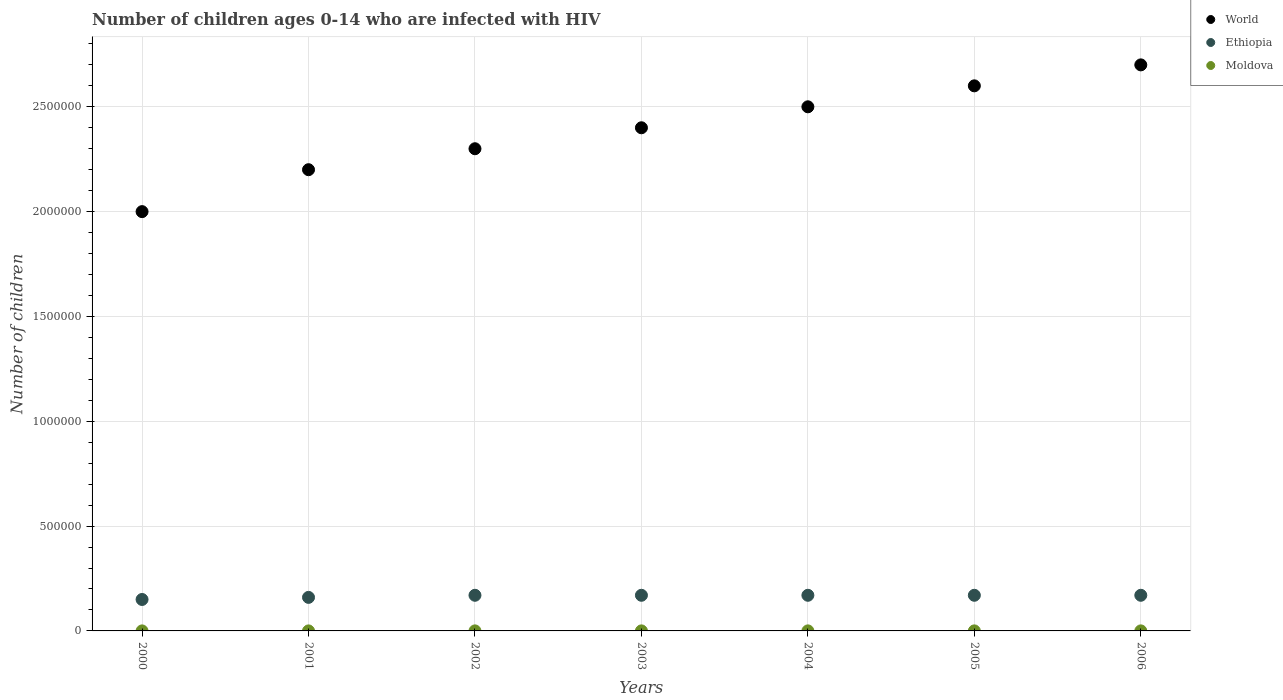Is the number of dotlines equal to the number of legend labels?
Keep it short and to the point. Yes. What is the number of HIV infected children in World in 2001?
Provide a short and direct response. 2.20e+06. Across all years, what is the maximum number of HIV infected children in Moldova?
Provide a short and direct response. 200. Across all years, what is the minimum number of HIV infected children in Ethiopia?
Your answer should be very brief. 1.50e+05. What is the total number of HIV infected children in Moldova in the graph?
Ensure brevity in your answer.  1200. What is the difference between the number of HIV infected children in World in 2003 and that in 2004?
Your response must be concise. -1.00e+05. What is the difference between the number of HIV infected children in Moldova in 2006 and the number of HIV infected children in World in 2002?
Provide a short and direct response. -2.30e+06. What is the average number of HIV infected children in Moldova per year?
Provide a short and direct response. 171.43. In the year 2000, what is the difference between the number of HIV infected children in World and number of HIV infected children in Moldova?
Keep it short and to the point. 2.00e+06. In how many years, is the number of HIV infected children in Ethiopia greater than 600000?
Provide a short and direct response. 0. What is the ratio of the number of HIV infected children in Moldova in 2001 to that in 2006?
Your answer should be very brief. 0.5. What is the difference between the highest and the lowest number of HIV infected children in World?
Give a very brief answer. 7.00e+05. In how many years, is the number of HIV infected children in Moldova greater than the average number of HIV infected children in Moldova taken over all years?
Your response must be concise. 5. Is the sum of the number of HIV infected children in World in 2001 and 2004 greater than the maximum number of HIV infected children in Moldova across all years?
Offer a terse response. Yes. Is it the case that in every year, the sum of the number of HIV infected children in World and number of HIV infected children in Moldova  is greater than the number of HIV infected children in Ethiopia?
Your response must be concise. Yes. Does the number of HIV infected children in Moldova monotonically increase over the years?
Offer a very short reply. No. How many dotlines are there?
Give a very brief answer. 3. How many years are there in the graph?
Your response must be concise. 7. What is the difference between two consecutive major ticks on the Y-axis?
Offer a terse response. 5.00e+05. Are the values on the major ticks of Y-axis written in scientific E-notation?
Ensure brevity in your answer.  No. Does the graph contain any zero values?
Your answer should be very brief. No. How many legend labels are there?
Keep it short and to the point. 3. How are the legend labels stacked?
Your answer should be very brief. Vertical. What is the title of the graph?
Keep it short and to the point. Number of children ages 0-14 who are infected with HIV. Does "Peru" appear as one of the legend labels in the graph?
Offer a terse response. No. What is the label or title of the Y-axis?
Your answer should be compact. Number of children. What is the Number of children in Ethiopia in 2000?
Make the answer very short. 1.50e+05. What is the Number of children in Moldova in 2000?
Provide a succinct answer. 100. What is the Number of children in World in 2001?
Ensure brevity in your answer.  2.20e+06. What is the Number of children of Moldova in 2001?
Ensure brevity in your answer.  100. What is the Number of children in World in 2002?
Offer a very short reply. 2.30e+06. What is the Number of children of World in 2003?
Make the answer very short. 2.40e+06. What is the Number of children of World in 2004?
Give a very brief answer. 2.50e+06. What is the Number of children in Ethiopia in 2004?
Offer a terse response. 1.70e+05. What is the Number of children in Moldova in 2004?
Offer a very short reply. 200. What is the Number of children of World in 2005?
Your answer should be compact. 2.60e+06. What is the Number of children of Ethiopia in 2005?
Your response must be concise. 1.70e+05. What is the Number of children in World in 2006?
Your answer should be compact. 2.70e+06. What is the Number of children of Ethiopia in 2006?
Give a very brief answer. 1.70e+05. What is the Number of children of Moldova in 2006?
Your response must be concise. 200. Across all years, what is the maximum Number of children in World?
Your response must be concise. 2.70e+06. Across all years, what is the maximum Number of children of Ethiopia?
Your answer should be compact. 1.70e+05. Across all years, what is the maximum Number of children in Moldova?
Make the answer very short. 200. Across all years, what is the minimum Number of children in Ethiopia?
Ensure brevity in your answer.  1.50e+05. Across all years, what is the minimum Number of children of Moldova?
Give a very brief answer. 100. What is the total Number of children of World in the graph?
Your response must be concise. 1.67e+07. What is the total Number of children of Ethiopia in the graph?
Offer a terse response. 1.16e+06. What is the total Number of children of Moldova in the graph?
Your answer should be very brief. 1200. What is the difference between the Number of children in World in 2000 and that in 2001?
Offer a very short reply. -2.00e+05. What is the difference between the Number of children of Ethiopia in 2000 and that in 2001?
Provide a short and direct response. -10000. What is the difference between the Number of children in Moldova in 2000 and that in 2001?
Provide a short and direct response. 0. What is the difference between the Number of children of World in 2000 and that in 2002?
Your answer should be very brief. -3.00e+05. What is the difference between the Number of children of Moldova in 2000 and that in 2002?
Offer a very short reply. -100. What is the difference between the Number of children in World in 2000 and that in 2003?
Offer a very short reply. -4.00e+05. What is the difference between the Number of children of Moldova in 2000 and that in 2003?
Give a very brief answer. -100. What is the difference between the Number of children of World in 2000 and that in 2004?
Make the answer very short. -5.00e+05. What is the difference between the Number of children in Moldova in 2000 and that in 2004?
Provide a succinct answer. -100. What is the difference between the Number of children of World in 2000 and that in 2005?
Provide a succinct answer. -6.00e+05. What is the difference between the Number of children in Moldova in 2000 and that in 2005?
Your answer should be compact. -100. What is the difference between the Number of children in World in 2000 and that in 2006?
Keep it short and to the point. -7.00e+05. What is the difference between the Number of children of Moldova in 2000 and that in 2006?
Give a very brief answer. -100. What is the difference between the Number of children in Ethiopia in 2001 and that in 2002?
Provide a short and direct response. -10000. What is the difference between the Number of children of Moldova in 2001 and that in 2002?
Offer a very short reply. -100. What is the difference between the Number of children of World in 2001 and that in 2003?
Your response must be concise. -2.00e+05. What is the difference between the Number of children of Moldova in 2001 and that in 2003?
Make the answer very short. -100. What is the difference between the Number of children of World in 2001 and that in 2004?
Make the answer very short. -3.00e+05. What is the difference between the Number of children in Moldova in 2001 and that in 2004?
Give a very brief answer. -100. What is the difference between the Number of children in World in 2001 and that in 2005?
Give a very brief answer. -4.00e+05. What is the difference between the Number of children in Moldova in 2001 and that in 2005?
Keep it short and to the point. -100. What is the difference between the Number of children of World in 2001 and that in 2006?
Your response must be concise. -5.00e+05. What is the difference between the Number of children of Ethiopia in 2001 and that in 2006?
Provide a succinct answer. -10000. What is the difference between the Number of children of Moldova in 2001 and that in 2006?
Make the answer very short. -100. What is the difference between the Number of children of World in 2002 and that in 2003?
Ensure brevity in your answer.  -1.00e+05. What is the difference between the Number of children in Ethiopia in 2002 and that in 2003?
Give a very brief answer. 0. What is the difference between the Number of children in Moldova in 2002 and that in 2003?
Offer a very short reply. 0. What is the difference between the Number of children in World in 2002 and that in 2004?
Offer a very short reply. -2.00e+05. What is the difference between the Number of children in Ethiopia in 2002 and that in 2005?
Your response must be concise. 0. What is the difference between the Number of children of World in 2002 and that in 2006?
Give a very brief answer. -4.00e+05. What is the difference between the Number of children in Moldova in 2002 and that in 2006?
Keep it short and to the point. 0. What is the difference between the Number of children in Ethiopia in 2003 and that in 2004?
Offer a terse response. 0. What is the difference between the Number of children in Moldova in 2003 and that in 2004?
Ensure brevity in your answer.  0. What is the difference between the Number of children in Moldova in 2003 and that in 2005?
Your response must be concise. 0. What is the difference between the Number of children of World in 2004 and that in 2006?
Provide a short and direct response. -2.00e+05. What is the difference between the Number of children in Ethiopia in 2004 and that in 2006?
Provide a short and direct response. 0. What is the difference between the Number of children of Moldova in 2004 and that in 2006?
Your response must be concise. 0. What is the difference between the Number of children of World in 2005 and that in 2006?
Offer a terse response. -1.00e+05. What is the difference between the Number of children in World in 2000 and the Number of children in Ethiopia in 2001?
Offer a terse response. 1.84e+06. What is the difference between the Number of children of World in 2000 and the Number of children of Moldova in 2001?
Your answer should be compact. 2.00e+06. What is the difference between the Number of children in Ethiopia in 2000 and the Number of children in Moldova in 2001?
Give a very brief answer. 1.50e+05. What is the difference between the Number of children in World in 2000 and the Number of children in Ethiopia in 2002?
Keep it short and to the point. 1.83e+06. What is the difference between the Number of children of World in 2000 and the Number of children of Moldova in 2002?
Make the answer very short. 2.00e+06. What is the difference between the Number of children of Ethiopia in 2000 and the Number of children of Moldova in 2002?
Your answer should be very brief. 1.50e+05. What is the difference between the Number of children of World in 2000 and the Number of children of Ethiopia in 2003?
Provide a short and direct response. 1.83e+06. What is the difference between the Number of children in World in 2000 and the Number of children in Moldova in 2003?
Provide a short and direct response. 2.00e+06. What is the difference between the Number of children of Ethiopia in 2000 and the Number of children of Moldova in 2003?
Give a very brief answer. 1.50e+05. What is the difference between the Number of children in World in 2000 and the Number of children in Ethiopia in 2004?
Keep it short and to the point. 1.83e+06. What is the difference between the Number of children of World in 2000 and the Number of children of Moldova in 2004?
Keep it short and to the point. 2.00e+06. What is the difference between the Number of children of Ethiopia in 2000 and the Number of children of Moldova in 2004?
Your answer should be very brief. 1.50e+05. What is the difference between the Number of children of World in 2000 and the Number of children of Ethiopia in 2005?
Offer a very short reply. 1.83e+06. What is the difference between the Number of children in World in 2000 and the Number of children in Moldova in 2005?
Provide a short and direct response. 2.00e+06. What is the difference between the Number of children in Ethiopia in 2000 and the Number of children in Moldova in 2005?
Your answer should be compact. 1.50e+05. What is the difference between the Number of children in World in 2000 and the Number of children in Ethiopia in 2006?
Provide a succinct answer. 1.83e+06. What is the difference between the Number of children of World in 2000 and the Number of children of Moldova in 2006?
Keep it short and to the point. 2.00e+06. What is the difference between the Number of children in Ethiopia in 2000 and the Number of children in Moldova in 2006?
Give a very brief answer. 1.50e+05. What is the difference between the Number of children in World in 2001 and the Number of children in Ethiopia in 2002?
Offer a terse response. 2.03e+06. What is the difference between the Number of children in World in 2001 and the Number of children in Moldova in 2002?
Your answer should be very brief. 2.20e+06. What is the difference between the Number of children in Ethiopia in 2001 and the Number of children in Moldova in 2002?
Provide a succinct answer. 1.60e+05. What is the difference between the Number of children in World in 2001 and the Number of children in Ethiopia in 2003?
Provide a short and direct response. 2.03e+06. What is the difference between the Number of children in World in 2001 and the Number of children in Moldova in 2003?
Offer a very short reply. 2.20e+06. What is the difference between the Number of children in Ethiopia in 2001 and the Number of children in Moldova in 2003?
Provide a short and direct response. 1.60e+05. What is the difference between the Number of children of World in 2001 and the Number of children of Ethiopia in 2004?
Your answer should be compact. 2.03e+06. What is the difference between the Number of children in World in 2001 and the Number of children in Moldova in 2004?
Give a very brief answer. 2.20e+06. What is the difference between the Number of children of Ethiopia in 2001 and the Number of children of Moldova in 2004?
Ensure brevity in your answer.  1.60e+05. What is the difference between the Number of children in World in 2001 and the Number of children in Ethiopia in 2005?
Provide a succinct answer. 2.03e+06. What is the difference between the Number of children of World in 2001 and the Number of children of Moldova in 2005?
Make the answer very short. 2.20e+06. What is the difference between the Number of children of Ethiopia in 2001 and the Number of children of Moldova in 2005?
Your answer should be compact. 1.60e+05. What is the difference between the Number of children of World in 2001 and the Number of children of Ethiopia in 2006?
Provide a short and direct response. 2.03e+06. What is the difference between the Number of children in World in 2001 and the Number of children in Moldova in 2006?
Your answer should be compact. 2.20e+06. What is the difference between the Number of children of Ethiopia in 2001 and the Number of children of Moldova in 2006?
Your answer should be compact. 1.60e+05. What is the difference between the Number of children in World in 2002 and the Number of children in Ethiopia in 2003?
Provide a succinct answer. 2.13e+06. What is the difference between the Number of children of World in 2002 and the Number of children of Moldova in 2003?
Provide a succinct answer. 2.30e+06. What is the difference between the Number of children of Ethiopia in 2002 and the Number of children of Moldova in 2003?
Offer a terse response. 1.70e+05. What is the difference between the Number of children of World in 2002 and the Number of children of Ethiopia in 2004?
Provide a short and direct response. 2.13e+06. What is the difference between the Number of children in World in 2002 and the Number of children in Moldova in 2004?
Your answer should be compact. 2.30e+06. What is the difference between the Number of children of Ethiopia in 2002 and the Number of children of Moldova in 2004?
Give a very brief answer. 1.70e+05. What is the difference between the Number of children of World in 2002 and the Number of children of Ethiopia in 2005?
Offer a terse response. 2.13e+06. What is the difference between the Number of children in World in 2002 and the Number of children in Moldova in 2005?
Give a very brief answer. 2.30e+06. What is the difference between the Number of children of Ethiopia in 2002 and the Number of children of Moldova in 2005?
Give a very brief answer. 1.70e+05. What is the difference between the Number of children of World in 2002 and the Number of children of Ethiopia in 2006?
Offer a very short reply. 2.13e+06. What is the difference between the Number of children of World in 2002 and the Number of children of Moldova in 2006?
Ensure brevity in your answer.  2.30e+06. What is the difference between the Number of children in Ethiopia in 2002 and the Number of children in Moldova in 2006?
Your response must be concise. 1.70e+05. What is the difference between the Number of children in World in 2003 and the Number of children in Ethiopia in 2004?
Ensure brevity in your answer.  2.23e+06. What is the difference between the Number of children in World in 2003 and the Number of children in Moldova in 2004?
Offer a very short reply. 2.40e+06. What is the difference between the Number of children in Ethiopia in 2003 and the Number of children in Moldova in 2004?
Your answer should be very brief. 1.70e+05. What is the difference between the Number of children in World in 2003 and the Number of children in Ethiopia in 2005?
Ensure brevity in your answer.  2.23e+06. What is the difference between the Number of children of World in 2003 and the Number of children of Moldova in 2005?
Give a very brief answer. 2.40e+06. What is the difference between the Number of children of Ethiopia in 2003 and the Number of children of Moldova in 2005?
Your answer should be compact. 1.70e+05. What is the difference between the Number of children in World in 2003 and the Number of children in Ethiopia in 2006?
Ensure brevity in your answer.  2.23e+06. What is the difference between the Number of children of World in 2003 and the Number of children of Moldova in 2006?
Provide a succinct answer. 2.40e+06. What is the difference between the Number of children in Ethiopia in 2003 and the Number of children in Moldova in 2006?
Offer a very short reply. 1.70e+05. What is the difference between the Number of children of World in 2004 and the Number of children of Ethiopia in 2005?
Give a very brief answer. 2.33e+06. What is the difference between the Number of children of World in 2004 and the Number of children of Moldova in 2005?
Offer a terse response. 2.50e+06. What is the difference between the Number of children of Ethiopia in 2004 and the Number of children of Moldova in 2005?
Make the answer very short. 1.70e+05. What is the difference between the Number of children in World in 2004 and the Number of children in Ethiopia in 2006?
Keep it short and to the point. 2.33e+06. What is the difference between the Number of children in World in 2004 and the Number of children in Moldova in 2006?
Your answer should be compact. 2.50e+06. What is the difference between the Number of children of Ethiopia in 2004 and the Number of children of Moldova in 2006?
Give a very brief answer. 1.70e+05. What is the difference between the Number of children of World in 2005 and the Number of children of Ethiopia in 2006?
Ensure brevity in your answer.  2.43e+06. What is the difference between the Number of children of World in 2005 and the Number of children of Moldova in 2006?
Your response must be concise. 2.60e+06. What is the difference between the Number of children in Ethiopia in 2005 and the Number of children in Moldova in 2006?
Offer a very short reply. 1.70e+05. What is the average Number of children in World per year?
Offer a terse response. 2.39e+06. What is the average Number of children in Ethiopia per year?
Provide a succinct answer. 1.66e+05. What is the average Number of children of Moldova per year?
Your answer should be compact. 171.43. In the year 2000, what is the difference between the Number of children of World and Number of children of Ethiopia?
Give a very brief answer. 1.85e+06. In the year 2000, what is the difference between the Number of children in World and Number of children in Moldova?
Offer a terse response. 2.00e+06. In the year 2000, what is the difference between the Number of children in Ethiopia and Number of children in Moldova?
Give a very brief answer. 1.50e+05. In the year 2001, what is the difference between the Number of children in World and Number of children in Ethiopia?
Provide a short and direct response. 2.04e+06. In the year 2001, what is the difference between the Number of children of World and Number of children of Moldova?
Offer a terse response. 2.20e+06. In the year 2001, what is the difference between the Number of children in Ethiopia and Number of children in Moldova?
Give a very brief answer. 1.60e+05. In the year 2002, what is the difference between the Number of children of World and Number of children of Ethiopia?
Your answer should be compact. 2.13e+06. In the year 2002, what is the difference between the Number of children in World and Number of children in Moldova?
Your response must be concise. 2.30e+06. In the year 2002, what is the difference between the Number of children in Ethiopia and Number of children in Moldova?
Give a very brief answer. 1.70e+05. In the year 2003, what is the difference between the Number of children of World and Number of children of Ethiopia?
Give a very brief answer. 2.23e+06. In the year 2003, what is the difference between the Number of children of World and Number of children of Moldova?
Ensure brevity in your answer.  2.40e+06. In the year 2003, what is the difference between the Number of children of Ethiopia and Number of children of Moldova?
Your response must be concise. 1.70e+05. In the year 2004, what is the difference between the Number of children of World and Number of children of Ethiopia?
Your answer should be very brief. 2.33e+06. In the year 2004, what is the difference between the Number of children in World and Number of children in Moldova?
Your answer should be compact. 2.50e+06. In the year 2004, what is the difference between the Number of children in Ethiopia and Number of children in Moldova?
Offer a very short reply. 1.70e+05. In the year 2005, what is the difference between the Number of children of World and Number of children of Ethiopia?
Ensure brevity in your answer.  2.43e+06. In the year 2005, what is the difference between the Number of children in World and Number of children in Moldova?
Offer a very short reply. 2.60e+06. In the year 2005, what is the difference between the Number of children in Ethiopia and Number of children in Moldova?
Ensure brevity in your answer.  1.70e+05. In the year 2006, what is the difference between the Number of children of World and Number of children of Ethiopia?
Your response must be concise. 2.53e+06. In the year 2006, what is the difference between the Number of children of World and Number of children of Moldova?
Offer a very short reply. 2.70e+06. In the year 2006, what is the difference between the Number of children of Ethiopia and Number of children of Moldova?
Keep it short and to the point. 1.70e+05. What is the ratio of the Number of children in World in 2000 to that in 2002?
Keep it short and to the point. 0.87. What is the ratio of the Number of children of Ethiopia in 2000 to that in 2002?
Provide a short and direct response. 0.88. What is the ratio of the Number of children in Moldova in 2000 to that in 2002?
Ensure brevity in your answer.  0.5. What is the ratio of the Number of children of Ethiopia in 2000 to that in 2003?
Offer a terse response. 0.88. What is the ratio of the Number of children in Moldova in 2000 to that in 2003?
Make the answer very short. 0.5. What is the ratio of the Number of children in Ethiopia in 2000 to that in 2004?
Ensure brevity in your answer.  0.88. What is the ratio of the Number of children in World in 2000 to that in 2005?
Give a very brief answer. 0.77. What is the ratio of the Number of children of Ethiopia in 2000 to that in 2005?
Your answer should be compact. 0.88. What is the ratio of the Number of children in World in 2000 to that in 2006?
Your response must be concise. 0.74. What is the ratio of the Number of children in Ethiopia in 2000 to that in 2006?
Offer a very short reply. 0.88. What is the ratio of the Number of children of Moldova in 2000 to that in 2006?
Provide a short and direct response. 0.5. What is the ratio of the Number of children in World in 2001 to that in 2002?
Provide a succinct answer. 0.96. What is the ratio of the Number of children in Moldova in 2001 to that in 2004?
Make the answer very short. 0.5. What is the ratio of the Number of children in World in 2001 to that in 2005?
Ensure brevity in your answer.  0.85. What is the ratio of the Number of children in Ethiopia in 2001 to that in 2005?
Provide a succinct answer. 0.94. What is the ratio of the Number of children of Moldova in 2001 to that in 2005?
Provide a succinct answer. 0.5. What is the ratio of the Number of children of World in 2001 to that in 2006?
Make the answer very short. 0.81. What is the ratio of the Number of children in Ethiopia in 2001 to that in 2006?
Keep it short and to the point. 0.94. What is the ratio of the Number of children of Moldova in 2001 to that in 2006?
Provide a short and direct response. 0.5. What is the ratio of the Number of children in World in 2002 to that in 2003?
Offer a terse response. 0.96. What is the ratio of the Number of children in Ethiopia in 2002 to that in 2003?
Make the answer very short. 1. What is the ratio of the Number of children in Ethiopia in 2002 to that in 2004?
Your response must be concise. 1. What is the ratio of the Number of children in Moldova in 2002 to that in 2004?
Your answer should be compact. 1. What is the ratio of the Number of children of World in 2002 to that in 2005?
Offer a very short reply. 0.88. What is the ratio of the Number of children of World in 2002 to that in 2006?
Your answer should be compact. 0.85. What is the ratio of the Number of children of Ethiopia in 2002 to that in 2006?
Keep it short and to the point. 1. What is the ratio of the Number of children in Moldova in 2002 to that in 2006?
Offer a terse response. 1. What is the ratio of the Number of children of World in 2003 to that in 2004?
Provide a short and direct response. 0.96. What is the ratio of the Number of children of World in 2003 to that in 2005?
Provide a succinct answer. 0.92. What is the ratio of the Number of children in Moldova in 2003 to that in 2005?
Your answer should be compact. 1. What is the ratio of the Number of children of World in 2003 to that in 2006?
Your answer should be compact. 0.89. What is the ratio of the Number of children in Ethiopia in 2003 to that in 2006?
Keep it short and to the point. 1. What is the ratio of the Number of children in World in 2004 to that in 2005?
Offer a very short reply. 0.96. What is the ratio of the Number of children of Ethiopia in 2004 to that in 2005?
Make the answer very short. 1. What is the ratio of the Number of children of World in 2004 to that in 2006?
Ensure brevity in your answer.  0.93. What is the ratio of the Number of children in Moldova in 2004 to that in 2006?
Offer a terse response. 1. What is the ratio of the Number of children in Moldova in 2005 to that in 2006?
Keep it short and to the point. 1. What is the difference between the highest and the second highest Number of children of Ethiopia?
Make the answer very short. 0. What is the difference between the highest and the second highest Number of children in Moldova?
Keep it short and to the point. 0. What is the difference between the highest and the lowest Number of children of World?
Your answer should be very brief. 7.00e+05. What is the difference between the highest and the lowest Number of children in Ethiopia?
Offer a very short reply. 2.00e+04. What is the difference between the highest and the lowest Number of children of Moldova?
Offer a terse response. 100. 